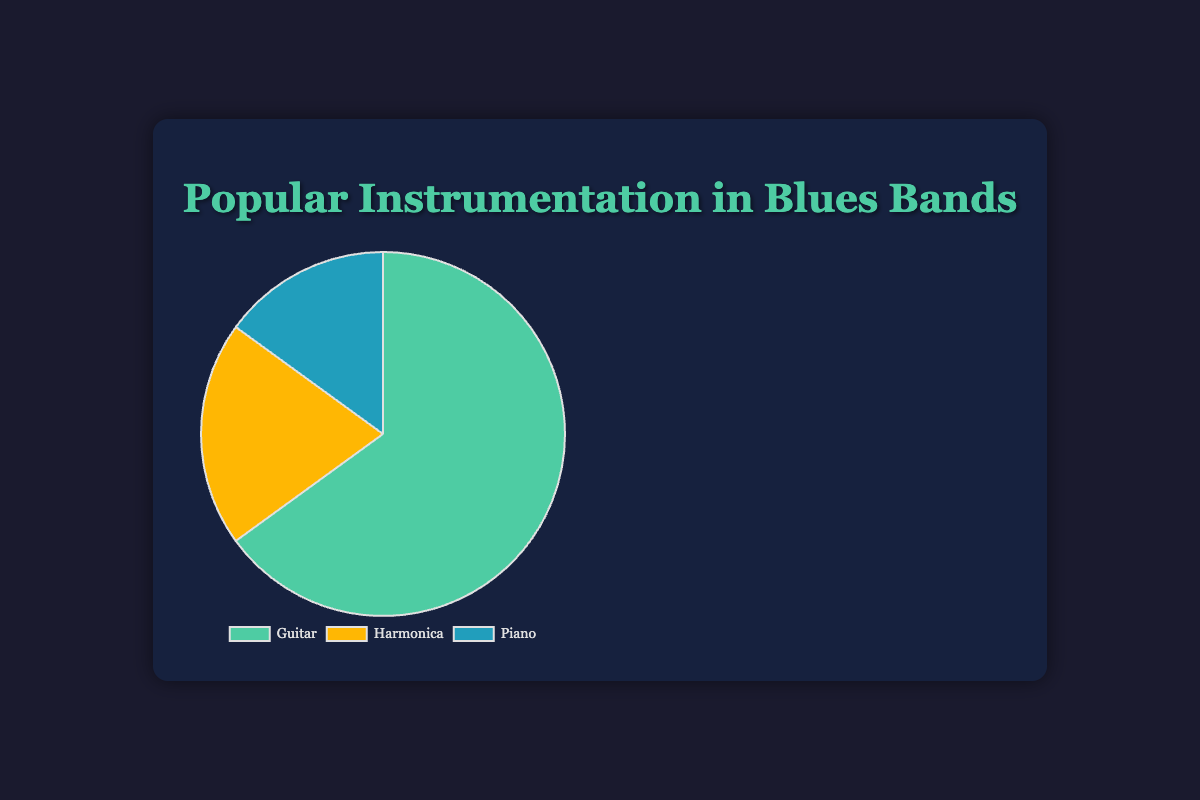Which instrument is the most popular in blues bands according to the chart? The pie chart shows the largest segment labeled 'Guitar' with 65 bands, indicating that it is the most popular instrument.
Answer: Guitar How many more bands feature Guitar than Harmonica? According to the chart, 65 bands feature Guitar and 20 bands feature Harmonica. The difference is 65 - 20 = 45 bands.
Answer: 45 What is the combined number of bands that feature Harmonica and Piano? The chart shows 20 bands with Harmonica and 15 bands with Piano. Their sum is 20 + 15 = 35 bands.
Answer: 35 What fraction of the total bands feature Piano? First, sum up all the bands: 65 (Guitar) + 20 (Harmonica) + 15 (Piano) = 100 bands. The fraction for Piano is 15/100, which simplifies to 3/20.
Answer: 3/20 Which has a smaller segment in the pie chart, Harmonica or Piano? By comparing the labeled sections, Harmonica has 20 bands and Piano has 15 bands. Piano has the smaller segment.
Answer: Piano If another instrument was added to the chart with 10 bands, would Guitar remain the most popular? Adding an instrument with 10 bands changes the total to 110 bands. Guitar still has 65 bands, making it the most popular compared to the other instruments.
Answer: Yes Given that the total number of bands is 100, what percentage of bands feature Harmonica? Harmonica has 20 bands out of a total of 100. The percentage is calculated as (20/100) * 100% = 20%.
Answer: 20% What is the ratio of bands with Guitar to bands with Piano? According to the chart, there are 65 bands with Guitar and 15 bands with Piano. The ratio is 65:15, which simplifies to 13:3.
Answer: 13:3 If the data represented bands in a festival lineup, and 10 more slots are added for Guitar-only bands, what would be the new percentage of Guitar bands? Adding 10 Guitar bands results in 65 + 10 = 75 Guitar bands. The new total is 100 + 10 = 110 bands. The new percentage is (75/110) * 100% ≈ 68.2%.
Answer: 68.2% Which instrument is represented by the color that appears the least often in the chart? Visually, the smallest segment of the pie chart which appears the least often is colored blue, representing Piano with 15 bands.
Answer: Piano 